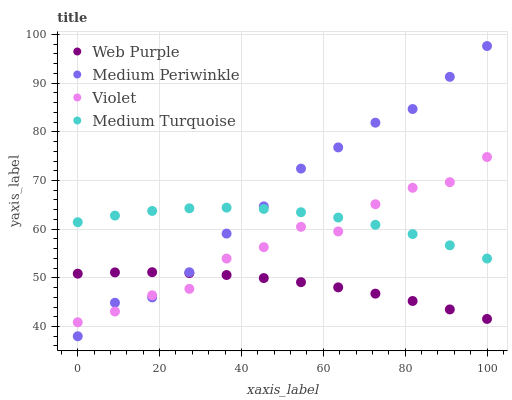Does Web Purple have the minimum area under the curve?
Answer yes or no. Yes. Does Medium Periwinkle have the maximum area under the curve?
Answer yes or no. Yes. Does Medium Turquoise have the minimum area under the curve?
Answer yes or no. No. Does Medium Turquoise have the maximum area under the curve?
Answer yes or no. No. Is Web Purple the smoothest?
Answer yes or no. Yes. Is Violet the roughest?
Answer yes or no. Yes. Is Medium Periwinkle the smoothest?
Answer yes or no. No. Is Medium Periwinkle the roughest?
Answer yes or no. No. Does Medium Periwinkle have the lowest value?
Answer yes or no. Yes. Does Medium Turquoise have the lowest value?
Answer yes or no. No. Does Medium Periwinkle have the highest value?
Answer yes or no. Yes. Does Medium Turquoise have the highest value?
Answer yes or no. No. Is Web Purple less than Medium Turquoise?
Answer yes or no. Yes. Is Medium Turquoise greater than Web Purple?
Answer yes or no. Yes. Does Medium Periwinkle intersect Violet?
Answer yes or no. Yes. Is Medium Periwinkle less than Violet?
Answer yes or no. No. Is Medium Periwinkle greater than Violet?
Answer yes or no. No. Does Web Purple intersect Medium Turquoise?
Answer yes or no. No. 